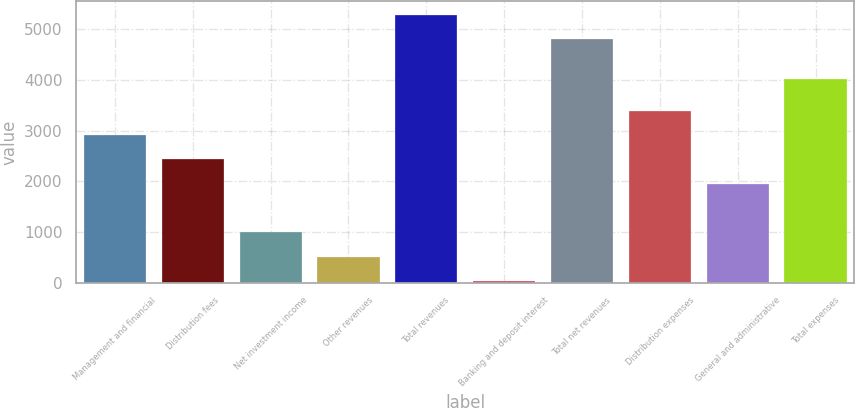<chart> <loc_0><loc_0><loc_500><loc_500><bar_chart><fcel>Management and financial<fcel>Distribution fees<fcel>Net investment income<fcel>Other revenues<fcel>Total revenues<fcel>Banking and deposit interest<fcel>Total net revenues<fcel>Distribution expenses<fcel>General and administrative<fcel>Total expenses<nl><fcel>2911.6<fcel>2431<fcel>989.2<fcel>508.6<fcel>5286.6<fcel>28<fcel>4806<fcel>3392.2<fcel>1950.4<fcel>4014<nl></chart> 